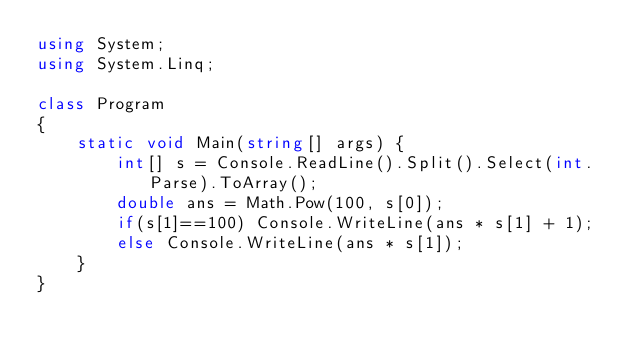Convert code to text. <code><loc_0><loc_0><loc_500><loc_500><_C#_>using System;
using System.Linq;
 
class Program
{
    static void Main(string[] args) {
        int[] s = Console.ReadLine().Split().Select(int.Parse).ToArray();
        double ans = Math.Pow(100, s[0]);
        if(s[1]==100) Console.WriteLine(ans * s[1] + 1);
        else Console.WriteLine(ans * s[1]);
    }
}</code> 